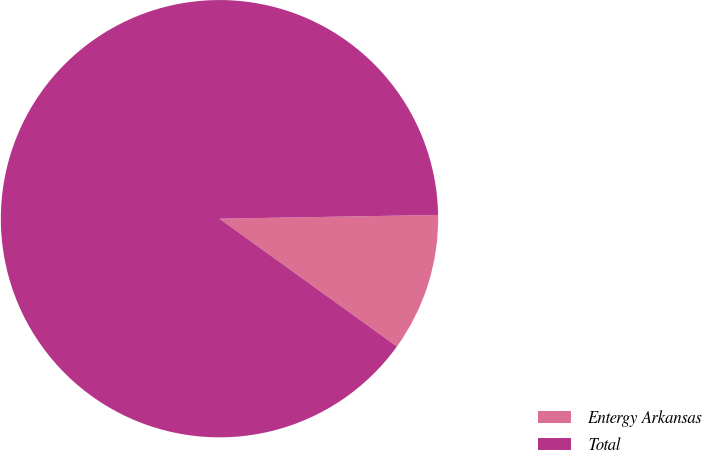Convert chart to OTSL. <chart><loc_0><loc_0><loc_500><loc_500><pie_chart><fcel>Entergy Arkansas<fcel>Total<nl><fcel>10.21%<fcel>89.79%<nl></chart> 